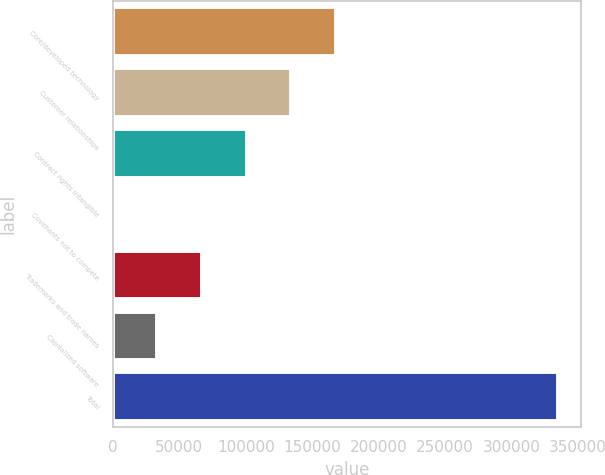Convert chart to OTSL. <chart><loc_0><loc_0><loc_500><loc_500><bar_chart><fcel>Core/developed technology<fcel>Customer relationships<fcel>Contract rights intangible<fcel>Covenants not to compete<fcel>Trademarks and trade names<fcel>Capitalized software<fcel>Total<nl><fcel>167738<fcel>134200<fcel>100662<fcel>50<fcel>67125<fcel>33587.5<fcel>335425<nl></chart> 